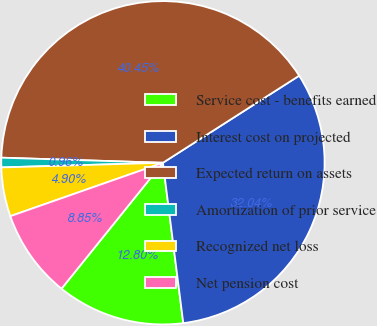Convert chart to OTSL. <chart><loc_0><loc_0><loc_500><loc_500><pie_chart><fcel>Service cost - benefits earned<fcel>Interest cost on projected<fcel>Expected return on assets<fcel>Amortization of prior service<fcel>Recognized net loss<fcel>Net pension cost<nl><fcel>12.8%<fcel>32.04%<fcel>40.45%<fcel>0.96%<fcel>4.9%<fcel>8.85%<nl></chart> 